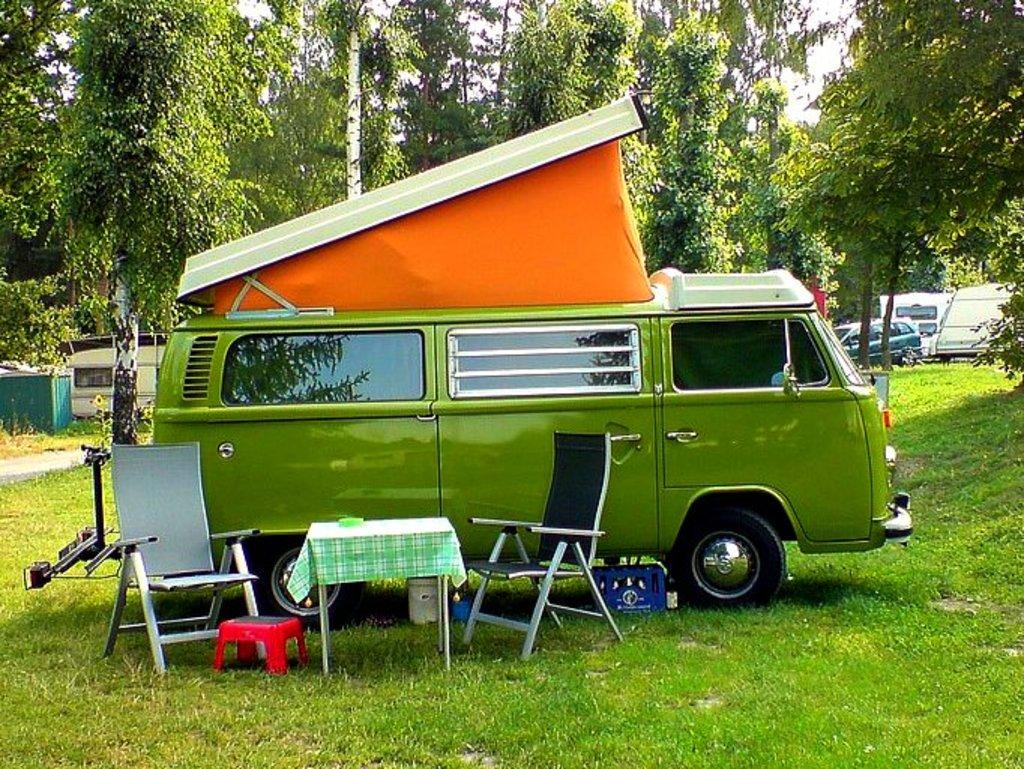What type of vehicle is in the image? There is a van in the image. What furniture is present in the image? There are two chairs and a table in the image. What can be seen in the background of the image? Trees are visible in the image. Are there any other vehicles in the image? Yes, there are vehicles parked in the image. Can you see a fight between snails happening in the image? There is no fight between snails present in the image. What type of glass object is visible in the image? There is no glass object visible in the image. 